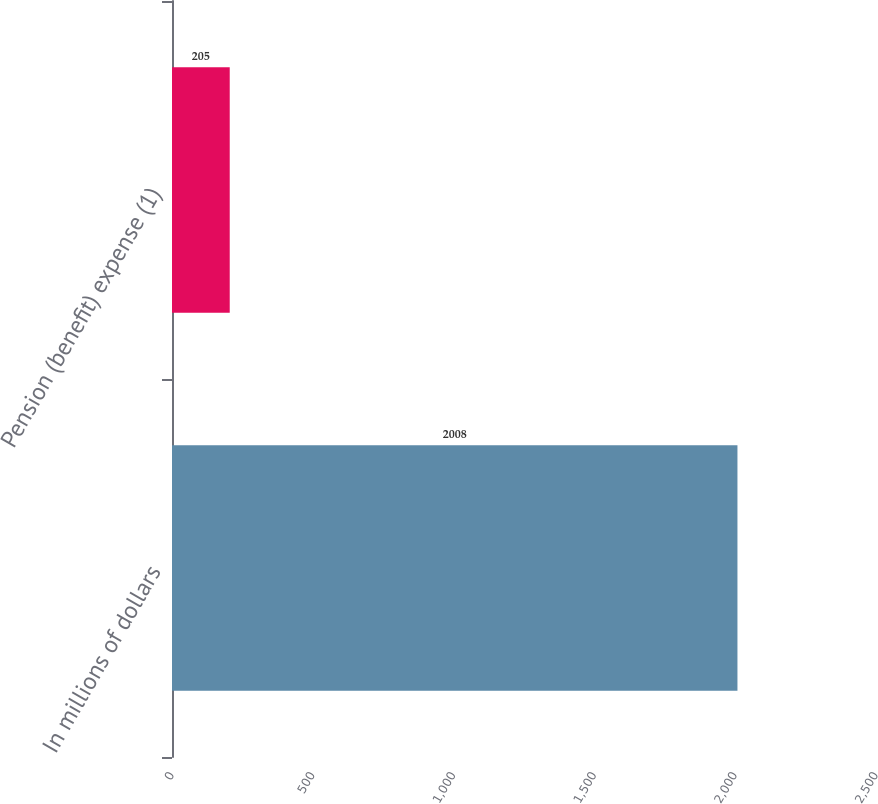Convert chart. <chart><loc_0><loc_0><loc_500><loc_500><bar_chart><fcel>In millions of dollars<fcel>Pension (benefit) expense (1)<nl><fcel>2008<fcel>205<nl></chart> 